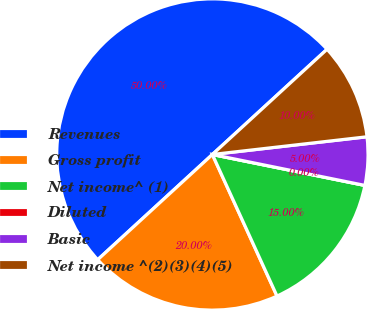Convert chart. <chart><loc_0><loc_0><loc_500><loc_500><pie_chart><fcel>Revenues<fcel>Gross profit<fcel>Net income^ (1)<fcel>Diluted<fcel>Basic<fcel>Net income ^(2)(3)(4)(5)<nl><fcel>50.0%<fcel>20.0%<fcel>15.0%<fcel>0.0%<fcel>5.0%<fcel>10.0%<nl></chart> 